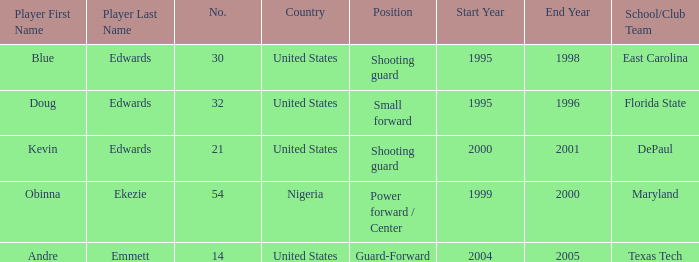Which position did kevin edwards play for Shooting guard. 